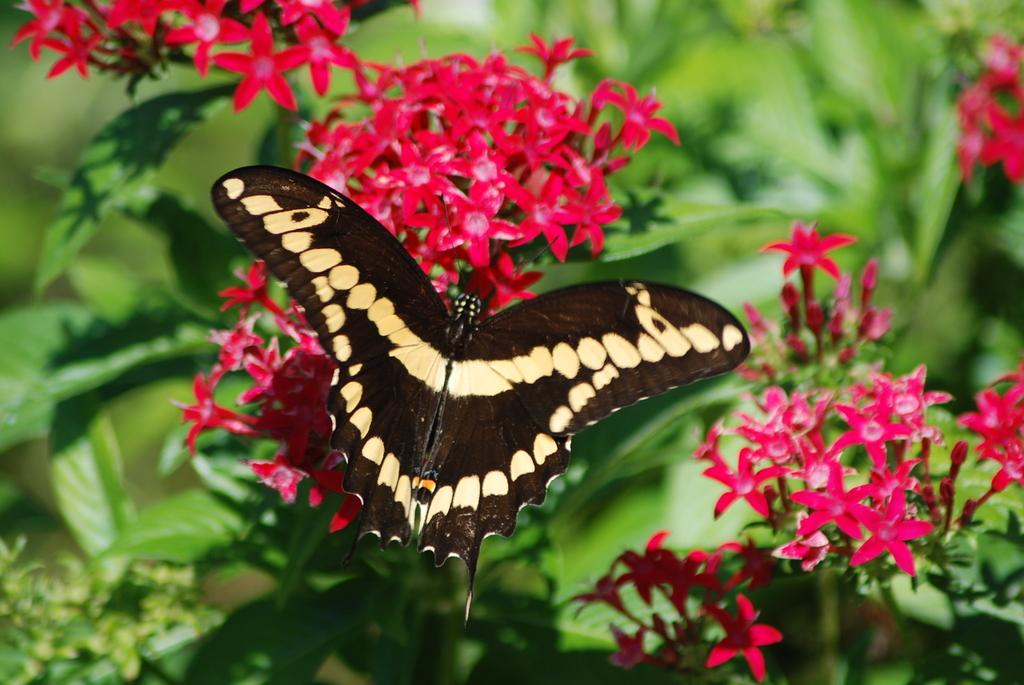What type of animal can be seen in the image? There is a butterfly in the image. What other living organisms are present in the image? There are flowers in the image. What color is predominant in the background of the image? The background of the image is green. What type of sofa can be seen in the image? There is no sofa present in the image. Is there any mention of payment in the image? There is no reference to payment in the image. 